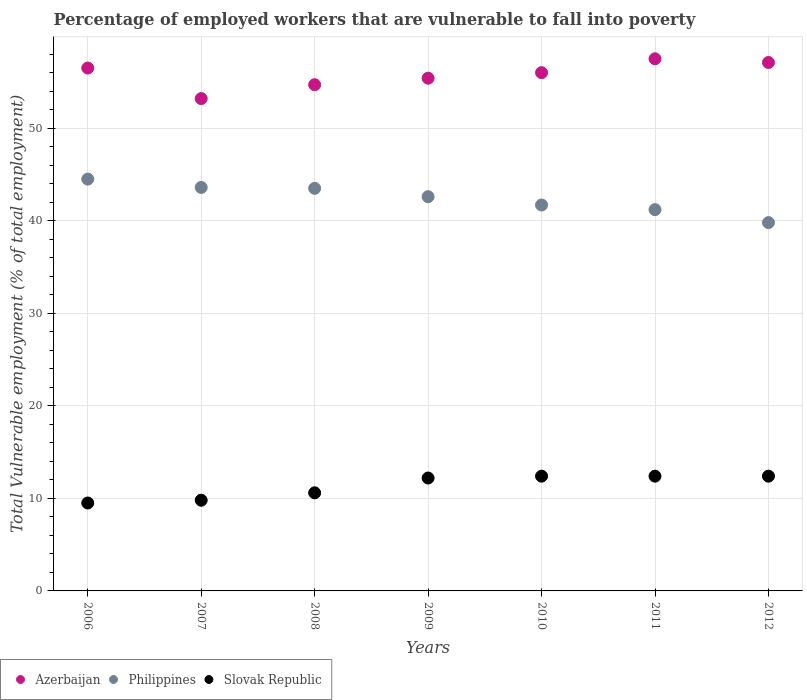What is the percentage of employed workers who are vulnerable to fall into poverty in Slovak Republic in 2007?
Provide a short and direct response. 9.8. Across all years, what is the maximum percentage of employed workers who are vulnerable to fall into poverty in Slovak Republic?
Offer a terse response. 12.4. Across all years, what is the minimum percentage of employed workers who are vulnerable to fall into poverty in Philippines?
Your answer should be compact. 39.8. In which year was the percentage of employed workers who are vulnerable to fall into poverty in Azerbaijan maximum?
Provide a succinct answer. 2011. In which year was the percentage of employed workers who are vulnerable to fall into poverty in Philippines minimum?
Make the answer very short. 2012. What is the total percentage of employed workers who are vulnerable to fall into poverty in Philippines in the graph?
Make the answer very short. 296.9. What is the difference between the percentage of employed workers who are vulnerable to fall into poverty in Azerbaijan in 2008 and that in 2012?
Provide a short and direct response. -2.4. What is the difference between the percentage of employed workers who are vulnerable to fall into poverty in Slovak Republic in 2006 and the percentage of employed workers who are vulnerable to fall into poverty in Azerbaijan in 2010?
Provide a short and direct response. -46.5. What is the average percentage of employed workers who are vulnerable to fall into poverty in Slovak Republic per year?
Ensure brevity in your answer.  11.33. In the year 2007, what is the difference between the percentage of employed workers who are vulnerable to fall into poverty in Philippines and percentage of employed workers who are vulnerable to fall into poverty in Azerbaijan?
Make the answer very short. -9.6. What is the ratio of the percentage of employed workers who are vulnerable to fall into poverty in Slovak Republic in 2008 to that in 2011?
Your answer should be compact. 0.85. Is the percentage of employed workers who are vulnerable to fall into poverty in Philippines in 2008 less than that in 2009?
Keep it short and to the point. No. What is the difference between the highest and the second highest percentage of employed workers who are vulnerable to fall into poverty in Philippines?
Make the answer very short. 0.9. What is the difference between the highest and the lowest percentage of employed workers who are vulnerable to fall into poverty in Slovak Republic?
Your answer should be very brief. 2.9. In how many years, is the percentage of employed workers who are vulnerable to fall into poverty in Philippines greater than the average percentage of employed workers who are vulnerable to fall into poverty in Philippines taken over all years?
Ensure brevity in your answer.  4. Is it the case that in every year, the sum of the percentage of employed workers who are vulnerable to fall into poverty in Slovak Republic and percentage of employed workers who are vulnerable to fall into poverty in Azerbaijan  is greater than the percentage of employed workers who are vulnerable to fall into poverty in Philippines?
Your response must be concise. Yes. Is the percentage of employed workers who are vulnerable to fall into poverty in Azerbaijan strictly less than the percentage of employed workers who are vulnerable to fall into poverty in Slovak Republic over the years?
Ensure brevity in your answer.  No. How many dotlines are there?
Your answer should be very brief. 3. How many years are there in the graph?
Ensure brevity in your answer.  7. What is the difference between two consecutive major ticks on the Y-axis?
Give a very brief answer. 10. Does the graph contain any zero values?
Ensure brevity in your answer.  No. Does the graph contain grids?
Offer a very short reply. Yes. Where does the legend appear in the graph?
Your answer should be compact. Bottom left. How many legend labels are there?
Offer a terse response. 3. What is the title of the graph?
Provide a short and direct response. Percentage of employed workers that are vulnerable to fall into poverty. Does "Monaco" appear as one of the legend labels in the graph?
Your answer should be very brief. No. What is the label or title of the Y-axis?
Keep it short and to the point. Total Vulnerable employment (% of total employment). What is the Total Vulnerable employment (% of total employment) in Azerbaijan in 2006?
Your response must be concise. 56.5. What is the Total Vulnerable employment (% of total employment) in Philippines in 2006?
Provide a succinct answer. 44.5. What is the Total Vulnerable employment (% of total employment) in Azerbaijan in 2007?
Offer a very short reply. 53.2. What is the Total Vulnerable employment (% of total employment) in Philippines in 2007?
Your answer should be very brief. 43.6. What is the Total Vulnerable employment (% of total employment) of Slovak Republic in 2007?
Your answer should be very brief. 9.8. What is the Total Vulnerable employment (% of total employment) of Azerbaijan in 2008?
Offer a terse response. 54.7. What is the Total Vulnerable employment (% of total employment) of Philippines in 2008?
Provide a short and direct response. 43.5. What is the Total Vulnerable employment (% of total employment) in Slovak Republic in 2008?
Keep it short and to the point. 10.6. What is the Total Vulnerable employment (% of total employment) in Azerbaijan in 2009?
Make the answer very short. 55.4. What is the Total Vulnerable employment (% of total employment) of Philippines in 2009?
Ensure brevity in your answer.  42.6. What is the Total Vulnerable employment (% of total employment) of Slovak Republic in 2009?
Offer a very short reply. 12.2. What is the Total Vulnerable employment (% of total employment) of Philippines in 2010?
Provide a succinct answer. 41.7. What is the Total Vulnerable employment (% of total employment) in Slovak Republic in 2010?
Make the answer very short. 12.4. What is the Total Vulnerable employment (% of total employment) of Azerbaijan in 2011?
Your response must be concise. 57.5. What is the Total Vulnerable employment (% of total employment) of Philippines in 2011?
Keep it short and to the point. 41.2. What is the Total Vulnerable employment (% of total employment) of Slovak Republic in 2011?
Make the answer very short. 12.4. What is the Total Vulnerable employment (% of total employment) of Azerbaijan in 2012?
Provide a short and direct response. 57.1. What is the Total Vulnerable employment (% of total employment) of Philippines in 2012?
Offer a very short reply. 39.8. What is the Total Vulnerable employment (% of total employment) of Slovak Republic in 2012?
Ensure brevity in your answer.  12.4. Across all years, what is the maximum Total Vulnerable employment (% of total employment) in Azerbaijan?
Make the answer very short. 57.5. Across all years, what is the maximum Total Vulnerable employment (% of total employment) of Philippines?
Make the answer very short. 44.5. Across all years, what is the maximum Total Vulnerable employment (% of total employment) of Slovak Republic?
Your answer should be compact. 12.4. Across all years, what is the minimum Total Vulnerable employment (% of total employment) in Azerbaijan?
Your response must be concise. 53.2. Across all years, what is the minimum Total Vulnerable employment (% of total employment) in Philippines?
Provide a succinct answer. 39.8. Across all years, what is the minimum Total Vulnerable employment (% of total employment) in Slovak Republic?
Ensure brevity in your answer.  9.5. What is the total Total Vulnerable employment (% of total employment) in Azerbaijan in the graph?
Offer a very short reply. 390.4. What is the total Total Vulnerable employment (% of total employment) in Philippines in the graph?
Provide a short and direct response. 296.9. What is the total Total Vulnerable employment (% of total employment) of Slovak Republic in the graph?
Provide a succinct answer. 79.3. What is the difference between the Total Vulnerable employment (% of total employment) of Azerbaijan in 2006 and that in 2007?
Your answer should be compact. 3.3. What is the difference between the Total Vulnerable employment (% of total employment) of Slovak Republic in 2006 and that in 2007?
Offer a very short reply. -0.3. What is the difference between the Total Vulnerable employment (% of total employment) of Azerbaijan in 2006 and that in 2008?
Your answer should be compact. 1.8. What is the difference between the Total Vulnerable employment (% of total employment) of Azerbaijan in 2006 and that in 2009?
Offer a very short reply. 1.1. What is the difference between the Total Vulnerable employment (% of total employment) in Azerbaijan in 2006 and that in 2010?
Provide a short and direct response. 0.5. What is the difference between the Total Vulnerable employment (% of total employment) of Slovak Republic in 2006 and that in 2010?
Give a very brief answer. -2.9. What is the difference between the Total Vulnerable employment (% of total employment) of Azerbaijan in 2006 and that in 2011?
Your answer should be compact. -1. What is the difference between the Total Vulnerable employment (% of total employment) in Philippines in 2006 and that in 2011?
Offer a very short reply. 3.3. What is the difference between the Total Vulnerable employment (% of total employment) of Slovak Republic in 2006 and that in 2011?
Keep it short and to the point. -2.9. What is the difference between the Total Vulnerable employment (% of total employment) in Azerbaijan in 2006 and that in 2012?
Ensure brevity in your answer.  -0.6. What is the difference between the Total Vulnerable employment (% of total employment) in Philippines in 2006 and that in 2012?
Your answer should be compact. 4.7. What is the difference between the Total Vulnerable employment (% of total employment) of Azerbaijan in 2007 and that in 2008?
Ensure brevity in your answer.  -1.5. What is the difference between the Total Vulnerable employment (% of total employment) in Slovak Republic in 2007 and that in 2008?
Provide a short and direct response. -0.8. What is the difference between the Total Vulnerable employment (% of total employment) in Azerbaijan in 2007 and that in 2009?
Make the answer very short. -2.2. What is the difference between the Total Vulnerable employment (% of total employment) of Slovak Republic in 2007 and that in 2009?
Your answer should be compact. -2.4. What is the difference between the Total Vulnerable employment (% of total employment) of Azerbaijan in 2007 and that in 2010?
Your response must be concise. -2.8. What is the difference between the Total Vulnerable employment (% of total employment) of Slovak Republic in 2007 and that in 2010?
Offer a very short reply. -2.6. What is the difference between the Total Vulnerable employment (% of total employment) of Azerbaijan in 2007 and that in 2011?
Offer a terse response. -4.3. What is the difference between the Total Vulnerable employment (% of total employment) of Slovak Republic in 2007 and that in 2012?
Make the answer very short. -2.6. What is the difference between the Total Vulnerable employment (% of total employment) in Philippines in 2008 and that in 2010?
Provide a succinct answer. 1.8. What is the difference between the Total Vulnerable employment (% of total employment) of Philippines in 2008 and that in 2011?
Your answer should be compact. 2.3. What is the difference between the Total Vulnerable employment (% of total employment) of Azerbaijan in 2008 and that in 2012?
Offer a very short reply. -2.4. What is the difference between the Total Vulnerable employment (% of total employment) of Philippines in 2008 and that in 2012?
Offer a very short reply. 3.7. What is the difference between the Total Vulnerable employment (% of total employment) in Slovak Republic in 2008 and that in 2012?
Ensure brevity in your answer.  -1.8. What is the difference between the Total Vulnerable employment (% of total employment) in Philippines in 2009 and that in 2010?
Your answer should be compact. 0.9. What is the difference between the Total Vulnerable employment (% of total employment) of Slovak Republic in 2009 and that in 2010?
Make the answer very short. -0.2. What is the difference between the Total Vulnerable employment (% of total employment) of Philippines in 2009 and that in 2011?
Make the answer very short. 1.4. What is the difference between the Total Vulnerable employment (% of total employment) of Azerbaijan in 2009 and that in 2012?
Offer a terse response. -1.7. What is the difference between the Total Vulnerable employment (% of total employment) of Slovak Republic in 2009 and that in 2012?
Your answer should be very brief. -0.2. What is the difference between the Total Vulnerable employment (% of total employment) of Slovak Republic in 2010 and that in 2011?
Your response must be concise. 0. What is the difference between the Total Vulnerable employment (% of total employment) of Philippines in 2010 and that in 2012?
Provide a short and direct response. 1.9. What is the difference between the Total Vulnerable employment (% of total employment) in Slovak Republic in 2010 and that in 2012?
Offer a very short reply. 0. What is the difference between the Total Vulnerable employment (% of total employment) in Azerbaijan in 2011 and that in 2012?
Ensure brevity in your answer.  0.4. What is the difference between the Total Vulnerable employment (% of total employment) in Azerbaijan in 2006 and the Total Vulnerable employment (% of total employment) in Philippines in 2007?
Give a very brief answer. 12.9. What is the difference between the Total Vulnerable employment (% of total employment) in Azerbaijan in 2006 and the Total Vulnerable employment (% of total employment) in Slovak Republic in 2007?
Ensure brevity in your answer.  46.7. What is the difference between the Total Vulnerable employment (% of total employment) of Philippines in 2006 and the Total Vulnerable employment (% of total employment) of Slovak Republic in 2007?
Your answer should be compact. 34.7. What is the difference between the Total Vulnerable employment (% of total employment) of Azerbaijan in 2006 and the Total Vulnerable employment (% of total employment) of Slovak Republic in 2008?
Your answer should be very brief. 45.9. What is the difference between the Total Vulnerable employment (% of total employment) in Philippines in 2006 and the Total Vulnerable employment (% of total employment) in Slovak Republic in 2008?
Provide a short and direct response. 33.9. What is the difference between the Total Vulnerable employment (% of total employment) in Azerbaijan in 2006 and the Total Vulnerable employment (% of total employment) in Philippines in 2009?
Give a very brief answer. 13.9. What is the difference between the Total Vulnerable employment (% of total employment) of Azerbaijan in 2006 and the Total Vulnerable employment (% of total employment) of Slovak Republic in 2009?
Keep it short and to the point. 44.3. What is the difference between the Total Vulnerable employment (% of total employment) of Philippines in 2006 and the Total Vulnerable employment (% of total employment) of Slovak Republic in 2009?
Your response must be concise. 32.3. What is the difference between the Total Vulnerable employment (% of total employment) in Azerbaijan in 2006 and the Total Vulnerable employment (% of total employment) in Slovak Republic in 2010?
Provide a short and direct response. 44.1. What is the difference between the Total Vulnerable employment (% of total employment) in Philippines in 2006 and the Total Vulnerable employment (% of total employment) in Slovak Republic in 2010?
Give a very brief answer. 32.1. What is the difference between the Total Vulnerable employment (% of total employment) of Azerbaijan in 2006 and the Total Vulnerable employment (% of total employment) of Slovak Republic in 2011?
Your answer should be very brief. 44.1. What is the difference between the Total Vulnerable employment (% of total employment) in Philippines in 2006 and the Total Vulnerable employment (% of total employment) in Slovak Republic in 2011?
Your answer should be compact. 32.1. What is the difference between the Total Vulnerable employment (% of total employment) in Azerbaijan in 2006 and the Total Vulnerable employment (% of total employment) in Slovak Republic in 2012?
Offer a terse response. 44.1. What is the difference between the Total Vulnerable employment (% of total employment) of Philippines in 2006 and the Total Vulnerable employment (% of total employment) of Slovak Republic in 2012?
Ensure brevity in your answer.  32.1. What is the difference between the Total Vulnerable employment (% of total employment) in Azerbaijan in 2007 and the Total Vulnerable employment (% of total employment) in Slovak Republic in 2008?
Provide a succinct answer. 42.6. What is the difference between the Total Vulnerable employment (% of total employment) in Philippines in 2007 and the Total Vulnerable employment (% of total employment) in Slovak Republic in 2008?
Your response must be concise. 33. What is the difference between the Total Vulnerable employment (% of total employment) of Azerbaijan in 2007 and the Total Vulnerable employment (% of total employment) of Philippines in 2009?
Provide a short and direct response. 10.6. What is the difference between the Total Vulnerable employment (% of total employment) of Philippines in 2007 and the Total Vulnerable employment (% of total employment) of Slovak Republic in 2009?
Ensure brevity in your answer.  31.4. What is the difference between the Total Vulnerable employment (% of total employment) of Azerbaijan in 2007 and the Total Vulnerable employment (% of total employment) of Philippines in 2010?
Keep it short and to the point. 11.5. What is the difference between the Total Vulnerable employment (% of total employment) in Azerbaijan in 2007 and the Total Vulnerable employment (% of total employment) in Slovak Republic in 2010?
Offer a terse response. 40.8. What is the difference between the Total Vulnerable employment (% of total employment) of Philippines in 2007 and the Total Vulnerable employment (% of total employment) of Slovak Republic in 2010?
Offer a terse response. 31.2. What is the difference between the Total Vulnerable employment (% of total employment) of Azerbaijan in 2007 and the Total Vulnerable employment (% of total employment) of Philippines in 2011?
Ensure brevity in your answer.  12. What is the difference between the Total Vulnerable employment (% of total employment) of Azerbaijan in 2007 and the Total Vulnerable employment (% of total employment) of Slovak Republic in 2011?
Provide a short and direct response. 40.8. What is the difference between the Total Vulnerable employment (% of total employment) in Philippines in 2007 and the Total Vulnerable employment (% of total employment) in Slovak Republic in 2011?
Provide a short and direct response. 31.2. What is the difference between the Total Vulnerable employment (% of total employment) in Azerbaijan in 2007 and the Total Vulnerable employment (% of total employment) in Philippines in 2012?
Your answer should be very brief. 13.4. What is the difference between the Total Vulnerable employment (% of total employment) in Azerbaijan in 2007 and the Total Vulnerable employment (% of total employment) in Slovak Republic in 2012?
Your answer should be compact. 40.8. What is the difference between the Total Vulnerable employment (% of total employment) of Philippines in 2007 and the Total Vulnerable employment (% of total employment) of Slovak Republic in 2012?
Offer a terse response. 31.2. What is the difference between the Total Vulnerable employment (% of total employment) in Azerbaijan in 2008 and the Total Vulnerable employment (% of total employment) in Philippines in 2009?
Make the answer very short. 12.1. What is the difference between the Total Vulnerable employment (% of total employment) in Azerbaijan in 2008 and the Total Vulnerable employment (% of total employment) in Slovak Republic in 2009?
Provide a succinct answer. 42.5. What is the difference between the Total Vulnerable employment (% of total employment) in Philippines in 2008 and the Total Vulnerable employment (% of total employment) in Slovak Republic in 2009?
Keep it short and to the point. 31.3. What is the difference between the Total Vulnerable employment (% of total employment) of Azerbaijan in 2008 and the Total Vulnerable employment (% of total employment) of Philippines in 2010?
Your response must be concise. 13. What is the difference between the Total Vulnerable employment (% of total employment) in Azerbaijan in 2008 and the Total Vulnerable employment (% of total employment) in Slovak Republic in 2010?
Offer a very short reply. 42.3. What is the difference between the Total Vulnerable employment (% of total employment) of Philippines in 2008 and the Total Vulnerable employment (% of total employment) of Slovak Republic in 2010?
Give a very brief answer. 31.1. What is the difference between the Total Vulnerable employment (% of total employment) in Azerbaijan in 2008 and the Total Vulnerable employment (% of total employment) in Philippines in 2011?
Give a very brief answer. 13.5. What is the difference between the Total Vulnerable employment (% of total employment) of Azerbaijan in 2008 and the Total Vulnerable employment (% of total employment) of Slovak Republic in 2011?
Make the answer very short. 42.3. What is the difference between the Total Vulnerable employment (% of total employment) in Philippines in 2008 and the Total Vulnerable employment (% of total employment) in Slovak Republic in 2011?
Provide a short and direct response. 31.1. What is the difference between the Total Vulnerable employment (% of total employment) of Azerbaijan in 2008 and the Total Vulnerable employment (% of total employment) of Slovak Republic in 2012?
Your answer should be very brief. 42.3. What is the difference between the Total Vulnerable employment (% of total employment) of Philippines in 2008 and the Total Vulnerable employment (% of total employment) of Slovak Republic in 2012?
Your answer should be very brief. 31.1. What is the difference between the Total Vulnerable employment (% of total employment) in Azerbaijan in 2009 and the Total Vulnerable employment (% of total employment) in Slovak Republic in 2010?
Provide a short and direct response. 43. What is the difference between the Total Vulnerable employment (% of total employment) in Philippines in 2009 and the Total Vulnerable employment (% of total employment) in Slovak Republic in 2010?
Your response must be concise. 30.2. What is the difference between the Total Vulnerable employment (% of total employment) of Philippines in 2009 and the Total Vulnerable employment (% of total employment) of Slovak Republic in 2011?
Ensure brevity in your answer.  30.2. What is the difference between the Total Vulnerable employment (% of total employment) in Azerbaijan in 2009 and the Total Vulnerable employment (% of total employment) in Slovak Republic in 2012?
Offer a terse response. 43. What is the difference between the Total Vulnerable employment (% of total employment) in Philippines in 2009 and the Total Vulnerable employment (% of total employment) in Slovak Republic in 2012?
Offer a very short reply. 30.2. What is the difference between the Total Vulnerable employment (% of total employment) of Azerbaijan in 2010 and the Total Vulnerable employment (% of total employment) of Philippines in 2011?
Ensure brevity in your answer.  14.8. What is the difference between the Total Vulnerable employment (% of total employment) in Azerbaijan in 2010 and the Total Vulnerable employment (% of total employment) in Slovak Republic in 2011?
Your response must be concise. 43.6. What is the difference between the Total Vulnerable employment (% of total employment) of Philippines in 2010 and the Total Vulnerable employment (% of total employment) of Slovak Republic in 2011?
Provide a short and direct response. 29.3. What is the difference between the Total Vulnerable employment (% of total employment) in Azerbaijan in 2010 and the Total Vulnerable employment (% of total employment) in Philippines in 2012?
Your response must be concise. 16.2. What is the difference between the Total Vulnerable employment (% of total employment) in Azerbaijan in 2010 and the Total Vulnerable employment (% of total employment) in Slovak Republic in 2012?
Your answer should be compact. 43.6. What is the difference between the Total Vulnerable employment (% of total employment) in Philippines in 2010 and the Total Vulnerable employment (% of total employment) in Slovak Republic in 2012?
Provide a short and direct response. 29.3. What is the difference between the Total Vulnerable employment (% of total employment) in Azerbaijan in 2011 and the Total Vulnerable employment (% of total employment) in Philippines in 2012?
Offer a terse response. 17.7. What is the difference between the Total Vulnerable employment (% of total employment) in Azerbaijan in 2011 and the Total Vulnerable employment (% of total employment) in Slovak Republic in 2012?
Provide a short and direct response. 45.1. What is the difference between the Total Vulnerable employment (% of total employment) in Philippines in 2011 and the Total Vulnerable employment (% of total employment) in Slovak Republic in 2012?
Provide a short and direct response. 28.8. What is the average Total Vulnerable employment (% of total employment) in Azerbaijan per year?
Keep it short and to the point. 55.77. What is the average Total Vulnerable employment (% of total employment) of Philippines per year?
Provide a succinct answer. 42.41. What is the average Total Vulnerable employment (% of total employment) of Slovak Republic per year?
Provide a short and direct response. 11.33. In the year 2006, what is the difference between the Total Vulnerable employment (% of total employment) of Philippines and Total Vulnerable employment (% of total employment) of Slovak Republic?
Make the answer very short. 35. In the year 2007, what is the difference between the Total Vulnerable employment (% of total employment) in Azerbaijan and Total Vulnerable employment (% of total employment) in Philippines?
Give a very brief answer. 9.6. In the year 2007, what is the difference between the Total Vulnerable employment (% of total employment) of Azerbaijan and Total Vulnerable employment (% of total employment) of Slovak Republic?
Provide a succinct answer. 43.4. In the year 2007, what is the difference between the Total Vulnerable employment (% of total employment) in Philippines and Total Vulnerable employment (% of total employment) in Slovak Republic?
Offer a very short reply. 33.8. In the year 2008, what is the difference between the Total Vulnerable employment (% of total employment) in Azerbaijan and Total Vulnerable employment (% of total employment) in Philippines?
Provide a short and direct response. 11.2. In the year 2008, what is the difference between the Total Vulnerable employment (% of total employment) of Azerbaijan and Total Vulnerable employment (% of total employment) of Slovak Republic?
Your answer should be compact. 44.1. In the year 2008, what is the difference between the Total Vulnerable employment (% of total employment) of Philippines and Total Vulnerable employment (% of total employment) of Slovak Republic?
Your answer should be very brief. 32.9. In the year 2009, what is the difference between the Total Vulnerable employment (% of total employment) of Azerbaijan and Total Vulnerable employment (% of total employment) of Slovak Republic?
Make the answer very short. 43.2. In the year 2009, what is the difference between the Total Vulnerable employment (% of total employment) of Philippines and Total Vulnerable employment (% of total employment) of Slovak Republic?
Provide a short and direct response. 30.4. In the year 2010, what is the difference between the Total Vulnerable employment (% of total employment) of Azerbaijan and Total Vulnerable employment (% of total employment) of Philippines?
Ensure brevity in your answer.  14.3. In the year 2010, what is the difference between the Total Vulnerable employment (% of total employment) of Azerbaijan and Total Vulnerable employment (% of total employment) of Slovak Republic?
Provide a succinct answer. 43.6. In the year 2010, what is the difference between the Total Vulnerable employment (% of total employment) in Philippines and Total Vulnerable employment (% of total employment) in Slovak Republic?
Your answer should be very brief. 29.3. In the year 2011, what is the difference between the Total Vulnerable employment (% of total employment) in Azerbaijan and Total Vulnerable employment (% of total employment) in Philippines?
Give a very brief answer. 16.3. In the year 2011, what is the difference between the Total Vulnerable employment (% of total employment) in Azerbaijan and Total Vulnerable employment (% of total employment) in Slovak Republic?
Your answer should be compact. 45.1. In the year 2011, what is the difference between the Total Vulnerable employment (% of total employment) in Philippines and Total Vulnerable employment (% of total employment) in Slovak Republic?
Offer a very short reply. 28.8. In the year 2012, what is the difference between the Total Vulnerable employment (% of total employment) of Azerbaijan and Total Vulnerable employment (% of total employment) of Philippines?
Give a very brief answer. 17.3. In the year 2012, what is the difference between the Total Vulnerable employment (% of total employment) in Azerbaijan and Total Vulnerable employment (% of total employment) in Slovak Republic?
Offer a terse response. 44.7. In the year 2012, what is the difference between the Total Vulnerable employment (% of total employment) of Philippines and Total Vulnerable employment (% of total employment) of Slovak Republic?
Offer a very short reply. 27.4. What is the ratio of the Total Vulnerable employment (% of total employment) in Azerbaijan in 2006 to that in 2007?
Make the answer very short. 1.06. What is the ratio of the Total Vulnerable employment (% of total employment) of Philippines in 2006 to that in 2007?
Your answer should be very brief. 1.02. What is the ratio of the Total Vulnerable employment (% of total employment) of Slovak Republic in 2006 to that in 2007?
Your answer should be very brief. 0.97. What is the ratio of the Total Vulnerable employment (% of total employment) in Azerbaijan in 2006 to that in 2008?
Offer a terse response. 1.03. What is the ratio of the Total Vulnerable employment (% of total employment) in Philippines in 2006 to that in 2008?
Provide a succinct answer. 1.02. What is the ratio of the Total Vulnerable employment (% of total employment) of Slovak Republic in 2006 to that in 2008?
Your response must be concise. 0.9. What is the ratio of the Total Vulnerable employment (% of total employment) of Azerbaijan in 2006 to that in 2009?
Your answer should be compact. 1.02. What is the ratio of the Total Vulnerable employment (% of total employment) in Philippines in 2006 to that in 2009?
Your answer should be compact. 1.04. What is the ratio of the Total Vulnerable employment (% of total employment) of Slovak Republic in 2006 to that in 2009?
Your answer should be compact. 0.78. What is the ratio of the Total Vulnerable employment (% of total employment) in Azerbaijan in 2006 to that in 2010?
Your answer should be compact. 1.01. What is the ratio of the Total Vulnerable employment (% of total employment) of Philippines in 2006 to that in 2010?
Keep it short and to the point. 1.07. What is the ratio of the Total Vulnerable employment (% of total employment) in Slovak Republic in 2006 to that in 2010?
Ensure brevity in your answer.  0.77. What is the ratio of the Total Vulnerable employment (% of total employment) of Azerbaijan in 2006 to that in 2011?
Offer a terse response. 0.98. What is the ratio of the Total Vulnerable employment (% of total employment) in Philippines in 2006 to that in 2011?
Provide a succinct answer. 1.08. What is the ratio of the Total Vulnerable employment (% of total employment) of Slovak Republic in 2006 to that in 2011?
Ensure brevity in your answer.  0.77. What is the ratio of the Total Vulnerable employment (% of total employment) of Philippines in 2006 to that in 2012?
Ensure brevity in your answer.  1.12. What is the ratio of the Total Vulnerable employment (% of total employment) of Slovak Republic in 2006 to that in 2012?
Keep it short and to the point. 0.77. What is the ratio of the Total Vulnerable employment (% of total employment) in Azerbaijan in 2007 to that in 2008?
Ensure brevity in your answer.  0.97. What is the ratio of the Total Vulnerable employment (% of total employment) in Philippines in 2007 to that in 2008?
Keep it short and to the point. 1. What is the ratio of the Total Vulnerable employment (% of total employment) in Slovak Republic in 2007 to that in 2008?
Your answer should be compact. 0.92. What is the ratio of the Total Vulnerable employment (% of total employment) of Azerbaijan in 2007 to that in 2009?
Offer a terse response. 0.96. What is the ratio of the Total Vulnerable employment (% of total employment) in Philippines in 2007 to that in 2009?
Offer a terse response. 1.02. What is the ratio of the Total Vulnerable employment (% of total employment) in Slovak Republic in 2007 to that in 2009?
Provide a succinct answer. 0.8. What is the ratio of the Total Vulnerable employment (% of total employment) in Azerbaijan in 2007 to that in 2010?
Keep it short and to the point. 0.95. What is the ratio of the Total Vulnerable employment (% of total employment) of Philippines in 2007 to that in 2010?
Your answer should be compact. 1.05. What is the ratio of the Total Vulnerable employment (% of total employment) of Slovak Republic in 2007 to that in 2010?
Offer a very short reply. 0.79. What is the ratio of the Total Vulnerable employment (% of total employment) in Azerbaijan in 2007 to that in 2011?
Offer a very short reply. 0.93. What is the ratio of the Total Vulnerable employment (% of total employment) of Philippines in 2007 to that in 2011?
Keep it short and to the point. 1.06. What is the ratio of the Total Vulnerable employment (% of total employment) in Slovak Republic in 2007 to that in 2011?
Ensure brevity in your answer.  0.79. What is the ratio of the Total Vulnerable employment (% of total employment) of Azerbaijan in 2007 to that in 2012?
Your answer should be very brief. 0.93. What is the ratio of the Total Vulnerable employment (% of total employment) in Philippines in 2007 to that in 2012?
Your answer should be very brief. 1.1. What is the ratio of the Total Vulnerable employment (% of total employment) in Slovak Republic in 2007 to that in 2012?
Provide a short and direct response. 0.79. What is the ratio of the Total Vulnerable employment (% of total employment) in Azerbaijan in 2008 to that in 2009?
Provide a short and direct response. 0.99. What is the ratio of the Total Vulnerable employment (% of total employment) in Philippines in 2008 to that in 2009?
Keep it short and to the point. 1.02. What is the ratio of the Total Vulnerable employment (% of total employment) of Slovak Republic in 2008 to that in 2009?
Ensure brevity in your answer.  0.87. What is the ratio of the Total Vulnerable employment (% of total employment) in Azerbaijan in 2008 to that in 2010?
Provide a succinct answer. 0.98. What is the ratio of the Total Vulnerable employment (% of total employment) in Philippines in 2008 to that in 2010?
Provide a short and direct response. 1.04. What is the ratio of the Total Vulnerable employment (% of total employment) in Slovak Republic in 2008 to that in 2010?
Provide a short and direct response. 0.85. What is the ratio of the Total Vulnerable employment (% of total employment) in Azerbaijan in 2008 to that in 2011?
Your answer should be very brief. 0.95. What is the ratio of the Total Vulnerable employment (% of total employment) in Philippines in 2008 to that in 2011?
Provide a succinct answer. 1.06. What is the ratio of the Total Vulnerable employment (% of total employment) of Slovak Republic in 2008 to that in 2011?
Your response must be concise. 0.85. What is the ratio of the Total Vulnerable employment (% of total employment) of Azerbaijan in 2008 to that in 2012?
Offer a very short reply. 0.96. What is the ratio of the Total Vulnerable employment (% of total employment) of Philippines in 2008 to that in 2012?
Make the answer very short. 1.09. What is the ratio of the Total Vulnerable employment (% of total employment) in Slovak Republic in 2008 to that in 2012?
Your answer should be very brief. 0.85. What is the ratio of the Total Vulnerable employment (% of total employment) of Azerbaijan in 2009 to that in 2010?
Ensure brevity in your answer.  0.99. What is the ratio of the Total Vulnerable employment (% of total employment) in Philippines in 2009 to that in 2010?
Give a very brief answer. 1.02. What is the ratio of the Total Vulnerable employment (% of total employment) of Slovak Republic in 2009 to that in 2010?
Your answer should be compact. 0.98. What is the ratio of the Total Vulnerable employment (% of total employment) in Azerbaijan in 2009 to that in 2011?
Ensure brevity in your answer.  0.96. What is the ratio of the Total Vulnerable employment (% of total employment) in Philippines in 2009 to that in 2011?
Offer a terse response. 1.03. What is the ratio of the Total Vulnerable employment (% of total employment) in Slovak Republic in 2009 to that in 2011?
Provide a short and direct response. 0.98. What is the ratio of the Total Vulnerable employment (% of total employment) of Azerbaijan in 2009 to that in 2012?
Provide a succinct answer. 0.97. What is the ratio of the Total Vulnerable employment (% of total employment) of Philippines in 2009 to that in 2012?
Offer a very short reply. 1.07. What is the ratio of the Total Vulnerable employment (% of total employment) of Slovak Republic in 2009 to that in 2012?
Provide a short and direct response. 0.98. What is the ratio of the Total Vulnerable employment (% of total employment) of Azerbaijan in 2010 to that in 2011?
Your response must be concise. 0.97. What is the ratio of the Total Vulnerable employment (% of total employment) in Philippines in 2010 to that in 2011?
Your answer should be compact. 1.01. What is the ratio of the Total Vulnerable employment (% of total employment) in Slovak Republic in 2010 to that in 2011?
Offer a very short reply. 1. What is the ratio of the Total Vulnerable employment (% of total employment) in Azerbaijan in 2010 to that in 2012?
Keep it short and to the point. 0.98. What is the ratio of the Total Vulnerable employment (% of total employment) in Philippines in 2010 to that in 2012?
Keep it short and to the point. 1.05. What is the ratio of the Total Vulnerable employment (% of total employment) in Slovak Republic in 2010 to that in 2012?
Your answer should be very brief. 1. What is the ratio of the Total Vulnerable employment (% of total employment) in Azerbaijan in 2011 to that in 2012?
Make the answer very short. 1.01. What is the ratio of the Total Vulnerable employment (% of total employment) of Philippines in 2011 to that in 2012?
Provide a succinct answer. 1.04. What is the ratio of the Total Vulnerable employment (% of total employment) of Slovak Republic in 2011 to that in 2012?
Offer a very short reply. 1. What is the difference between the highest and the second highest Total Vulnerable employment (% of total employment) of Azerbaijan?
Your answer should be very brief. 0.4. What is the difference between the highest and the second highest Total Vulnerable employment (% of total employment) of Philippines?
Offer a terse response. 0.9. What is the difference between the highest and the lowest Total Vulnerable employment (% of total employment) in Slovak Republic?
Your response must be concise. 2.9. 